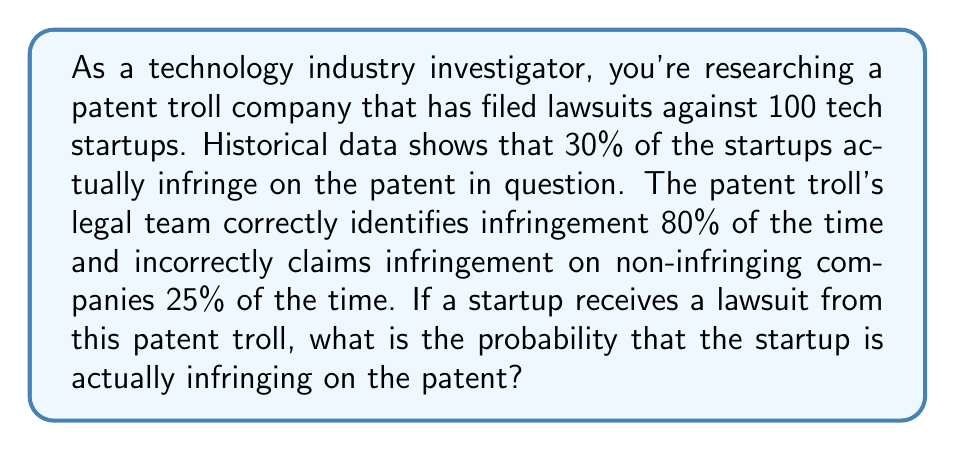Give your solution to this math problem. Let's approach this problem using Bayes' theorem. We'll define the following events:
A: The startup is actually infringing on the patent
B: The patent troll files a lawsuit against the startup

Given:
P(A) = 0.30 (prior probability of infringement)
P(B|A) = 0.80 (probability of lawsuit given infringement)
P(B|not A) = 0.25 (probability of lawsuit given no infringement)

We want to find P(A|B), the probability of infringement given that a lawsuit was filed.

Using Bayes' theorem:

$$ P(A|B) = \frac{P(B|A) \cdot P(A)}{P(B)} $$

To find P(B), we use the law of total probability:

$$ P(B) = P(B|A) \cdot P(A) + P(B|not A) \cdot P(not A) $$

$$ P(B) = 0.80 \cdot 0.30 + 0.25 \cdot (1 - 0.30) $$
$$ P(B) = 0.24 + 0.175 = 0.415 $$

Now we can plug this into Bayes' theorem:

$$ P(A|B) = \frac{0.80 \cdot 0.30}{0.415} $$
$$ P(A|B) = \frac{0.24}{0.415} \approx 0.5783 $$

Therefore, the probability that a startup is actually infringing on the patent, given that it received a lawsuit from the patent troll, is approximately 0.5783 or 57.83%.
Answer: 0.5783 (or 57.83%) 